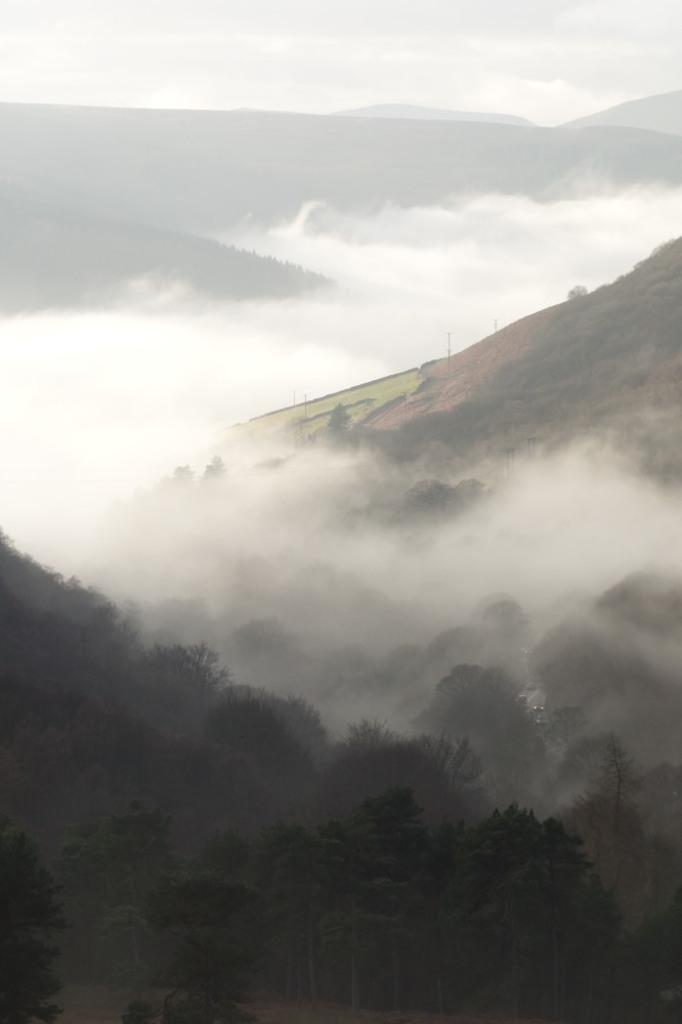What type of landscape can be seen in the image? There are hills in the image. What other natural elements are present in the image? There are trees in the image. How is the visibility in the image affected? The image is covered with fog. What type of education is being provided in the image? There is no indication of any educational activity in the image; it primarily features hills, trees, and fog. 